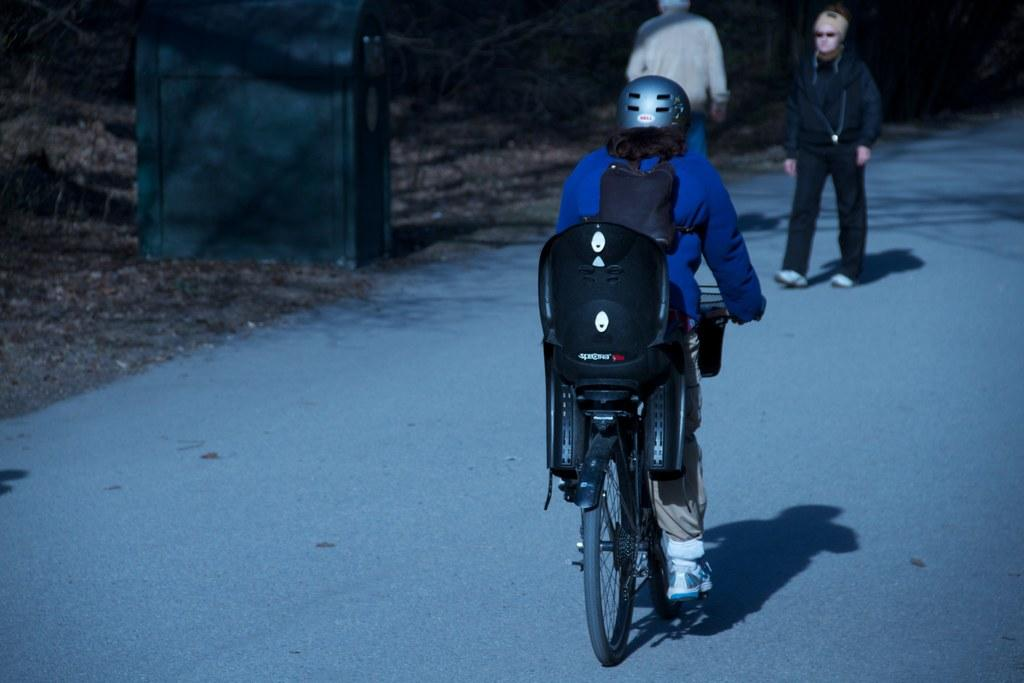How many people are in the image? There are three persons in the image. What is one person doing in the image? One person is riding a bicycle. What can be observed about the person riding the bicycle? The person riding the bicycle is wearing shoes. What type of feather can be seen on the caption of the image? There is no caption present in the image, and therefore no feather can be observed. 